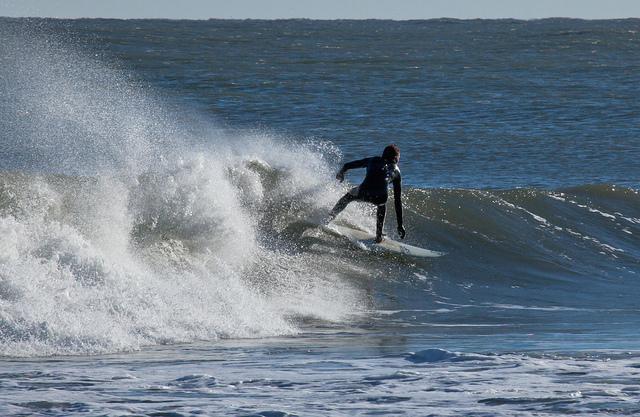Is the water cold?
Short answer required. Yes. How many people are in the water?
Short answer required. 1. Did the person fall off his surfboard?
Keep it brief. No. Is there a wave?
Write a very short answer. Yes. Is he standing on a surfboard?
Quick response, please. Yes. 